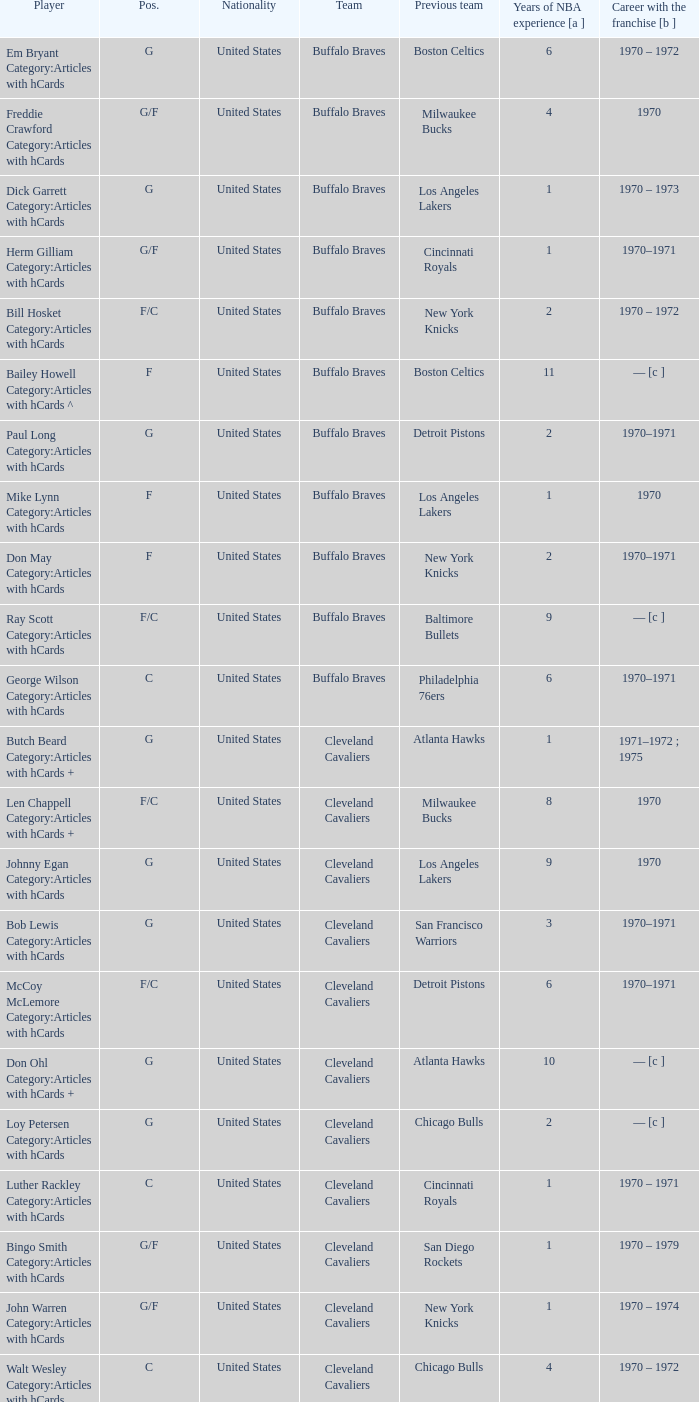Who is the player from the Buffalo Braves with the previous team Los Angeles Lakers and a career with the franchase in 1970? Mike Lynn Category:Articles with hCards. 